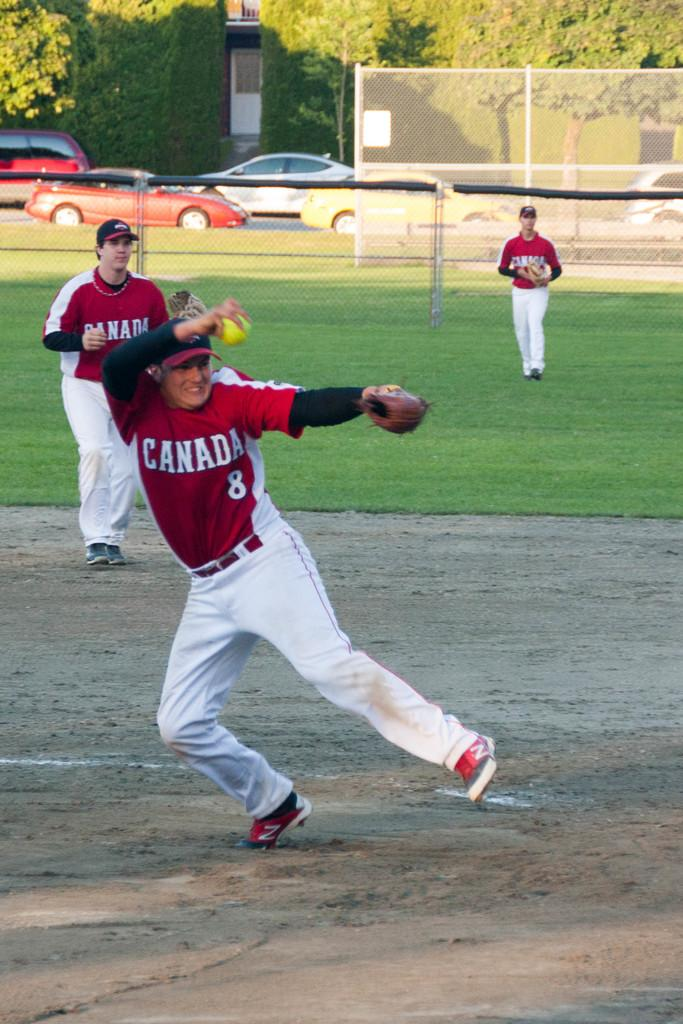<image>
Summarize the visual content of the image. Three ball players wear Canada uniforms as they participate in a baseball game. 